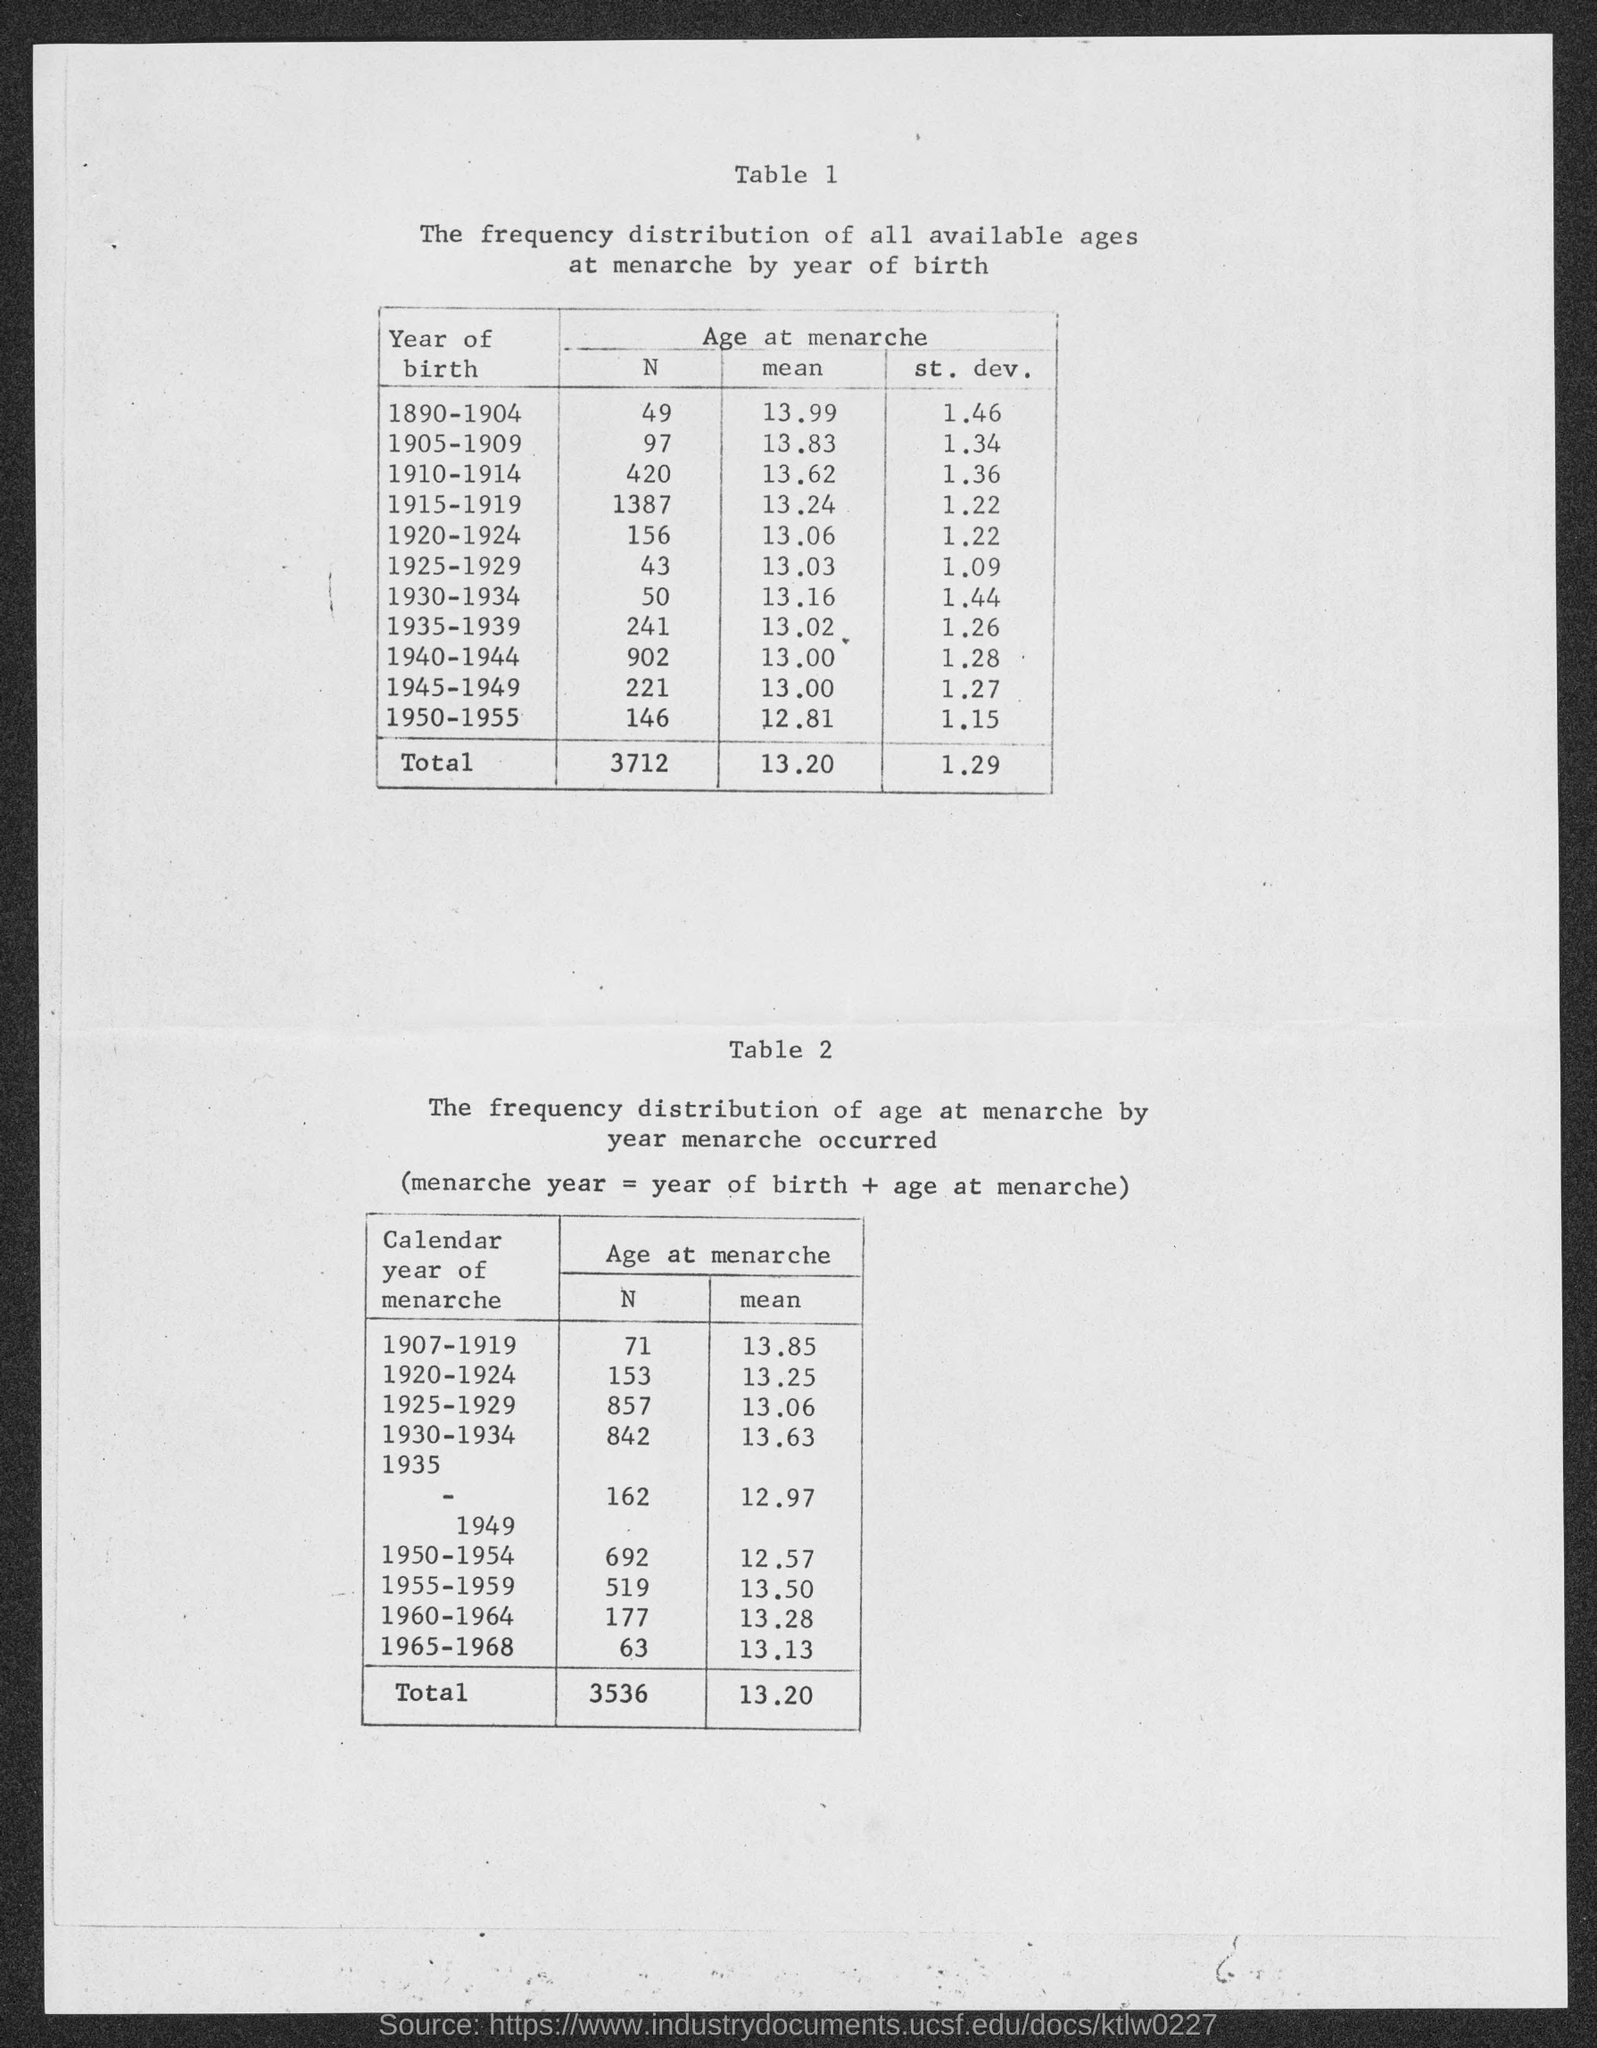What is the mean value for the year of birth 1890-1904 ?
Your response must be concise. 13.99. What is the mean value for the year of birth 1905-1909 ?
Offer a terse response. 13.83. What is the mean value for the year of birth 1915-1919 ?
Ensure brevity in your answer.  13.24. What is the total mean value mentioned in the given page ?
Your response must be concise. 13.20. 